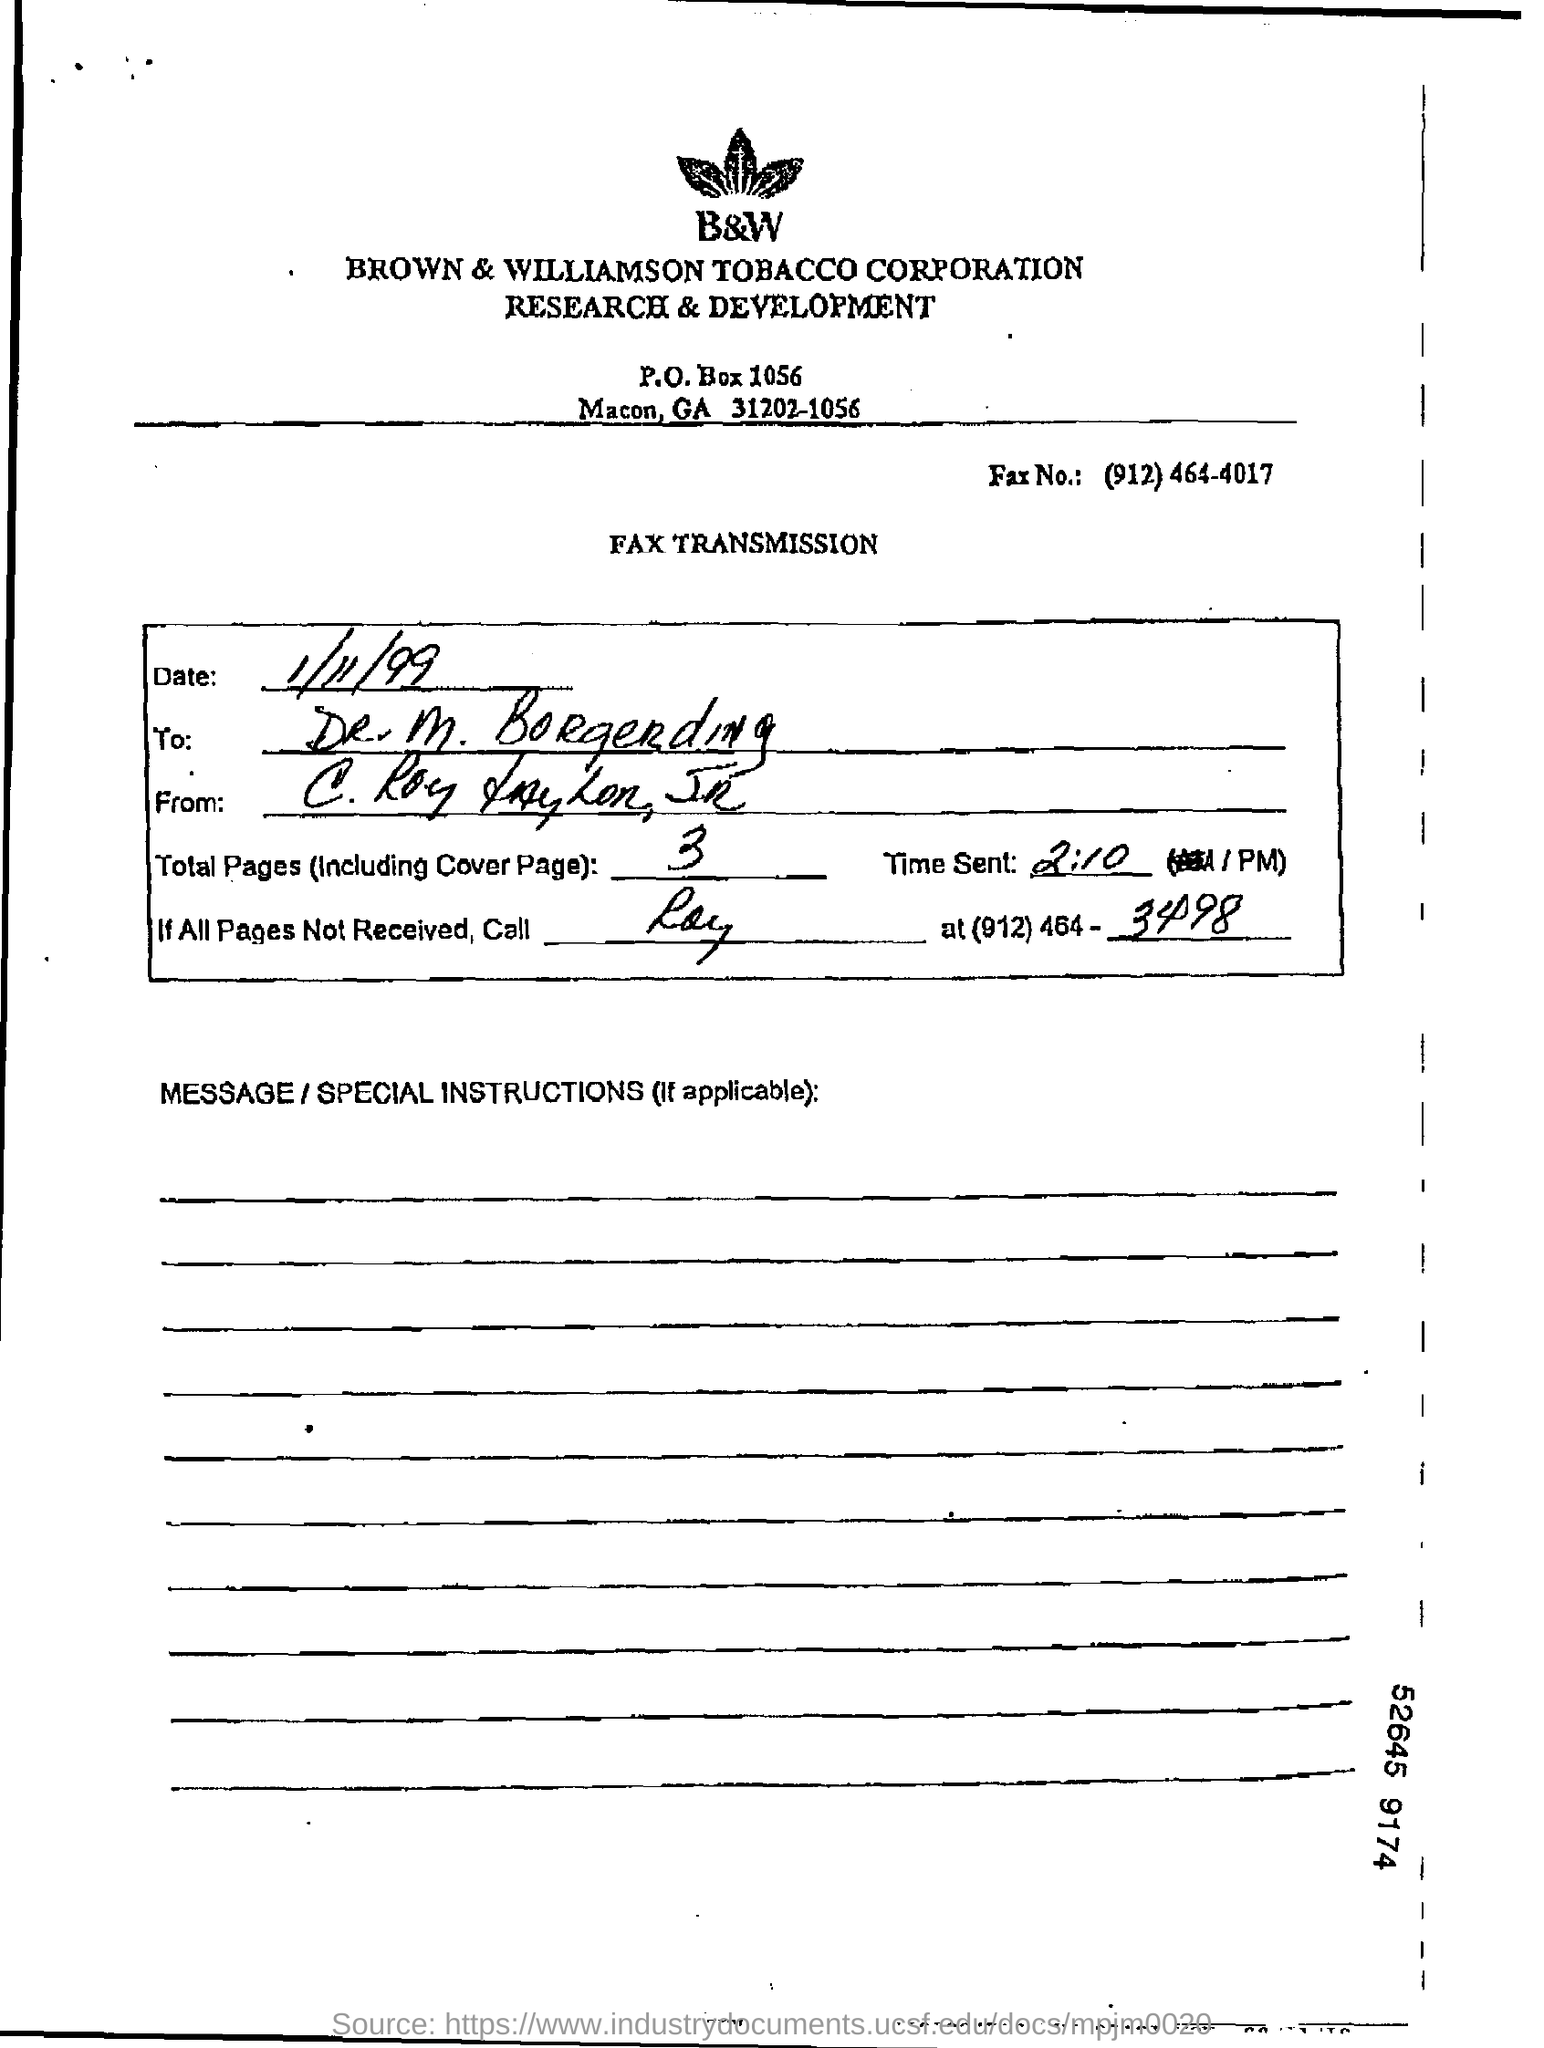Point out several critical features in this image. The full form of B&W is Brown & Williamson Tobacco Corporation. There are a total of three pages in the fax, including the cover page. The fax number is (912) 464-4017. The total number of pages, including the cover page, is three. 